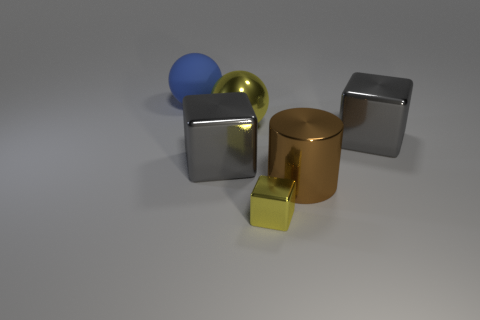Can you describe the lighting in the scene? The lighting in the scene comes from above, casting soft shadows directly underneath the objects, which indicates a diffuse light source that softens the shadows' edges. 